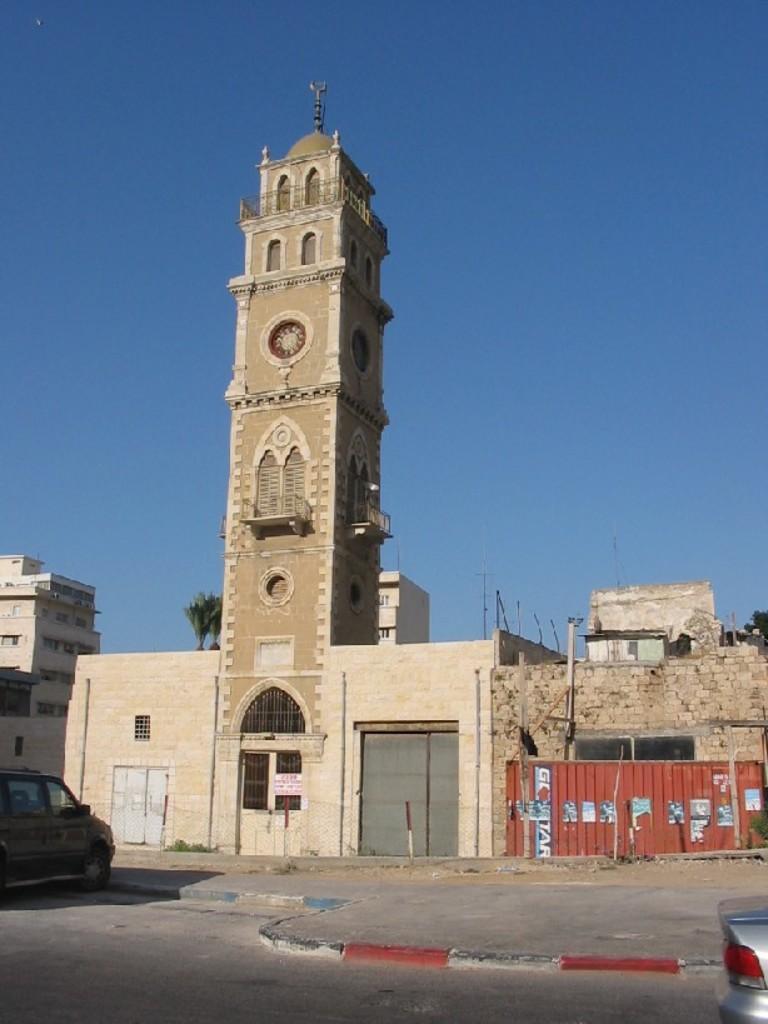Describe this image in one or two sentences. Here in this picture in the middle we can see a building tower present and beside that we can see other buildings also present and we can see windows and doors and on the road we can see cars present, in the far we can see trees present and we can see the sky is clear. 